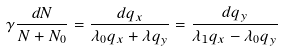<formula> <loc_0><loc_0><loc_500><loc_500>\gamma \frac { d N } { N + N _ { 0 } } = \frac { d q _ { x } } { \lambda _ { 0 } q _ { x } + \lambda q _ { y } } = \frac { d q _ { y } } { \lambda _ { 1 } q _ { x } - \lambda _ { 0 } q _ { y } }</formula> 